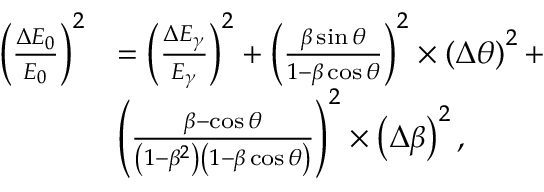<formula> <loc_0><loc_0><loc_500><loc_500>\begin{array} { r l } { \left ( \frac { \Delta { E _ { 0 } } } { E _ { 0 } } \right ) ^ { 2 } } & { = \left ( \frac { \Delta E _ { \gamma } } { E _ { \gamma } } \right ) ^ { 2 } + \left ( \frac { \beta \sin \theta } { 1 - \beta \cos \theta } \right ) ^ { 2 } \times \left ( \Delta \theta \right ) ^ { 2 } + } \\ & { \left ( \frac { \beta - \cos \theta } { \left ( 1 - \beta ^ { 2 } \right ) \left ( 1 - \beta \cos \theta \right ) } \right ) ^ { 2 } \times \left ( \Delta \beta \right ) ^ { 2 } , } \end{array}</formula> 